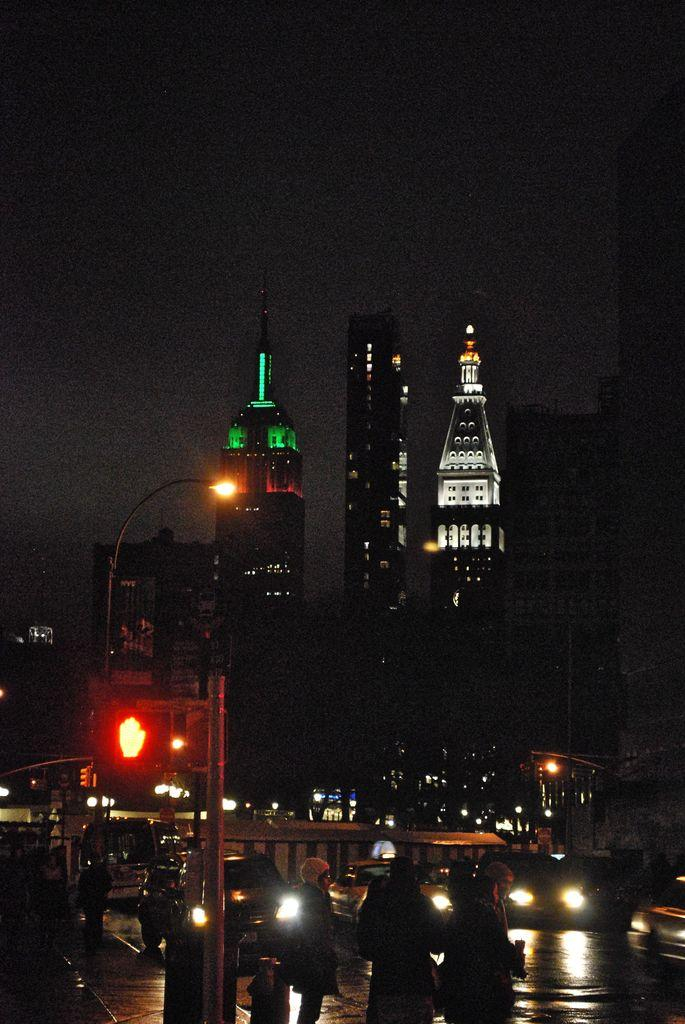What type of structures can be seen in the image? There are buildings in the image. What traffic control device is present in the image? There is a traffic light in the image. What type of illumination is present along the road in the image? There is a street light in the image. What type of transportation is visible on the road in the image? There are vehicles on the road in the image. What can be seen in the background of the image? The sky is visible in the background of the image. How many ghosts are present in the image? There are no ghosts present in the image. What is the amount of crowd visible in the image? There is no crowd visible in the image; it features individual vehicles and structures. 